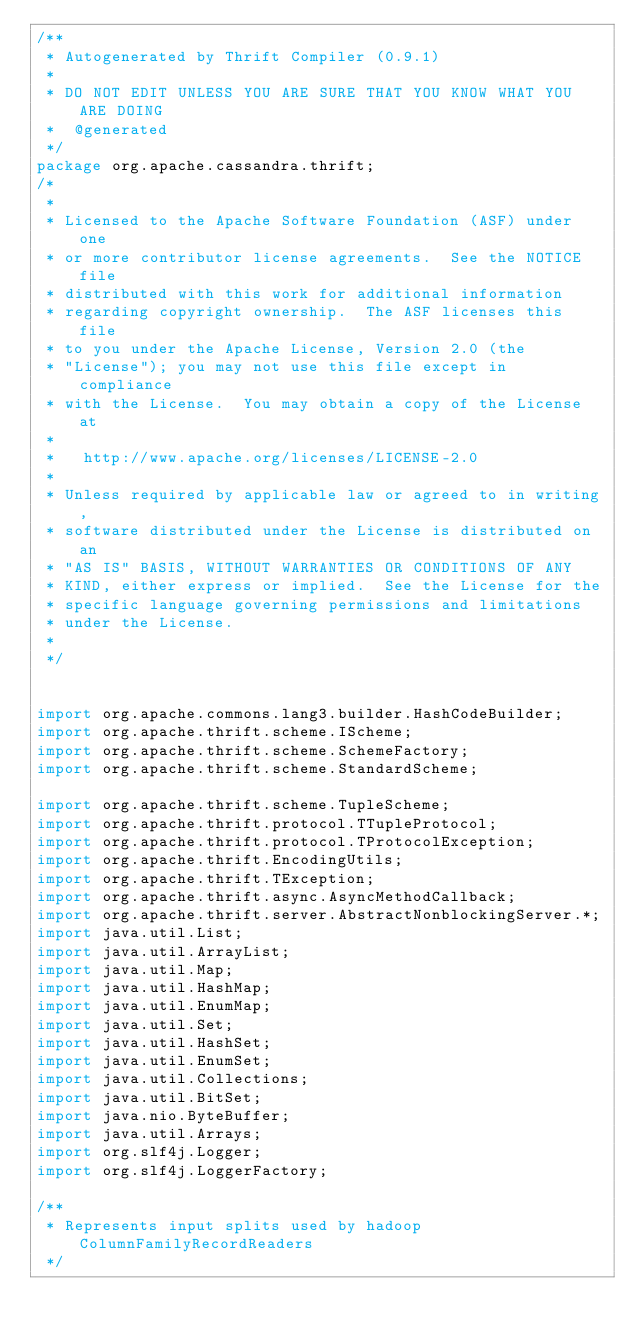<code> <loc_0><loc_0><loc_500><loc_500><_Java_>/**
 * Autogenerated by Thrift Compiler (0.9.1)
 *
 * DO NOT EDIT UNLESS YOU ARE SURE THAT YOU KNOW WHAT YOU ARE DOING
 *  @generated
 */
package org.apache.cassandra.thrift;
/*
 * 
 * Licensed to the Apache Software Foundation (ASF) under one
 * or more contributor license agreements.  See the NOTICE file
 * distributed with this work for additional information
 * regarding copyright ownership.  The ASF licenses this file
 * to you under the Apache License, Version 2.0 (the
 * "License"); you may not use this file except in compliance
 * with the License.  You may obtain a copy of the License at
 * 
 *   http://www.apache.org/licenses/LICENSE-2.0
 * 
 * Unless required by applicable law or agreed to in writing,
 * software distributed under the License is distributed on an
 * "AS IS" BASIS, WITHOUT WARRANTIES OR CONDITIONS OF ANY
 * KIND, either express or implied.  See the License for the
 * specific language governing permissions and limitations
 * under the License.
 * 
 */


import org.apache.commons.lang3.builder.HashCodeBuilder;
import org.apache.thrift.scheme.IScheme;
import org.apache.thrift.scheme.SchemeFactory;
import org.apache.thrift.scheme.StandardScheme;

import org.apache.thrift.scheme.TupleScheme;
import org.apache.thrift.protocol.TTupleProtocol;
import org.apache.thrift.protocol.TProtocolException;
import org.apache.thrift.EncodingUtils;
import org.apache.thrift.TException;
import org.apache.thrift.async.AsyncMethodCallback;
import org.apache.thrift.server.AbstractNonblockingServer.*;
import java.util.List;
import java.util.ArrayList;
import java.util.Map;
import java.util.HashMap;
import java.util.EnumMap;
import java.util.Set;
import java.util.HashSet;
import java.util.EnumSet;
import java.util.Collections;
import java.util.BitSet;
import java.nio.ByteBuffer;
import java.util.Arrays;
import org.slf4j.Logger;
import org.slf4j.LoggerFactory;

/**
 * Represents input splits used by hadoop ColumnFamilyRecordReaders
 */</code> 